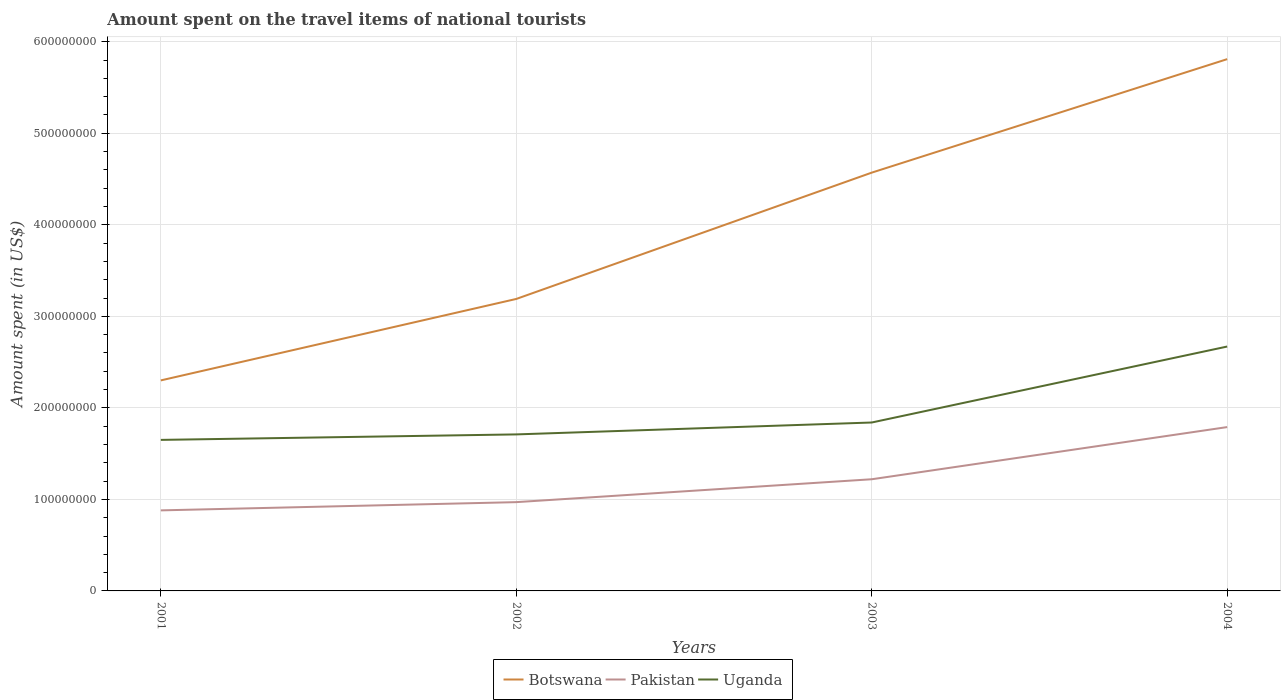Across all years, what is the maximum amount spent on the travel items of national tourists in Pakistan?
Your answer should be compact. 8.80e+07. In which year was the amount spent on the travel items of national tourists in Botswana maximum?
Ensure brevity in your answer.  2001. What is the total amount spent on the travel items of national tourists in Uganda in the graph?
Your answer should be very brief. -6.00e+06. What is the difference between the highest and the second highest amount spent on the travel items of national tourists in Uganda?
Offer a terse response. 1.02e+08. What is the difference between the highest and the lowest amount spent on the travel items of national tourists in Botswana?
Offer a very short reply. 2. Is the amount spent on the travel items of national tourists in Uganda strictly greater than the amount spent on the travel items of national tourists in Pakistan over the years?
Ensure brevity in your answer.  No. How many lines are there?
Make the answer very short. 3. Are the values on the major ticks of Y-axis written in scientific E-notation?
Your answer should be compact. No. How many legend labels are there?
Your answer should be very brief. 3. How are the legend labels stacked?
Offer a very short reply. Horizontal. What is the title of the graph?
Your answer should be compact. Amount spent on the travel items of national tourists. Does "Sub-Saharan Africa (developing only)" appear as one of the legend labels in the graph?
Offer a terse response. No. What is the label or title of the X-axis?
Offer a very short reply. Years. What is the label or title of the Y-axis?
Offer a terse response. Amount spent (in US$). What is the Amount spent (in US$) in Botswana in 2001?
Provide a succinct answer. 2.30e+08. What is the Amount spent (in US$) of Pakistan in 2001?
Your response must be concise. 8.80e+07. What is the Amount spent (in US$) in Uganda in 2001?
Offer a terse response. 1.65e+08. What is the Amount spent (in US$) in Botswana in 2002?
Give a very brief answer. 3.19e+08. What is the Amount spent (in US$) of Pakistan in 2002?
Make the answer very short. 9.70e+07. What is the Amount spent (in US$) of Uganda in 2002?
Offer a very short reply. 1.71e+08. What is the Amount spent (in US$) of Botswana in 2003?
Offer a terse response. 4.57e+08. What is the Amount spent (in US$) in Pakistan in 2003?
Give a very brief answer. 1.22e+08. What is the Amount spent (in US$) in Uganda in 2003?
Provide a succinct answer. 1.84e+08. What is the Amount spent (in US$) of Botswana in 2004?
Ensure brevity in your answer.  5.81e+08. What is the Amount spent (in US$) in Pakistan in 2004?
Make the answer very short. 1.79e+08. What is the Amount spent (in US$) in Uganda in 2004?
Offer a very short reply. 2.67e+08. Across all years, what is the maximum Amount spent (in US$) of Botswana?
Give a very brief answer. 5.81e+08. Across all years, what is the maximum Amount spent (in US$) of Pakistan?
Offer a terse response. 1.79e+08. Across all years, what is the maximum Amount spent (in US$) of Uganda?
Your answer should be compact. 2.67e+08. Across all years, what is the minimum Amount spent (in US$) in Botswana?
Offer a terse response. 2.30e+08. Across all years, what is the minimum Amount spent (in US$) in Pakistan?
Ensure brevity in your answer.  8.80e+07. Across all years, what is the minimum Amount spent (in US$) in Uganda?
Give a very brief answer. 1.65e+08. What is the total Amount spent (in US$) of Botswana in the graph?
Ensure brevity in your answer.  1.59e+09. What is the total Amount spent (in US$) of Pakistan in the graph?
Offer a very short reply. 4.86e+08. What is the total Amount spent (in US$) of Uganda in the graph?
Provide a short and direct response. 7.87e+08. What is the difference between the Amount spent (in US$) of Botswana in 2001 and that in 2002?
Your response must be concise. -8.90e+07. What is the difference between the Amount spent (in US$) in Pakistan in 2001 and that in 2002?
Make the answer very short. -9.00e+06. What is the difference between the Amount spent (in US$) in Uganda in 2001 and that in 2002?
Offer a terse response. -6.00e+06. What is the difference between the Amount spent (in US$) in Botswana in 2001 and that in 2003?
Your answer should be compact. -2.27e+08. What is the difference between the Amount spent (in US$) in Pakistan in 2001 and that in 2003?
Keep it short and to the point. -3.40e+07. What is the difference between the Amount spent (in US$) in Uganda in 2001 and that in 2003?
Your response must be concise. -1.90e+07. What is the difference between the Amount spent (in US$) in Botswana in 2001 and that in 2004?
Your answer should be very brief. -3.51e+08. What is the difference between the Amount spent (in US$) in Pakistan in 2001 and that in 2004?
Your response must be concise. -9.10e+07. What is the difference between the Amount spent (in US$) of Uganda in 2001 and that in 2004?
Keep it short and to the point. -1.02e+08. What is the difference between the Amount spent (in US$) in Botswana in 2002 and that in 2003?
Give a very brief answer. -1.38e+08. What is the difference between the Amount spent (in US$) of Pakistan in 2002 and that in 2003?
Your answer should be very brief. -2.50e+07. What is the difference between the Amount spent (in US$) of Uganda in 2002 and that in 2003?
Your response must be concise. -1.30e+07. What is the difference between the Amount spent (in US$) of Botswana in 2002 and that in 2004?
Your answer should be compact. -2.62e+08. What is the difference between the Amount spent (in US$) of Pakistan in 2002 and that in 2004?
Your answer should be very brief. -8.20e+07. What is the difference between the Amount spent (in US$) of Uganda in 2002 and that in 2004?
Your answer should be very brief. -9.60e+07. What is the difference between the Amount spent (in US$) of Botswana in 2003 and that in 2004?
Offer a very short reply. -1.24e+08. What is the difference between the Amount spent (in US$) in Pakistan in 2003 and that in 2004?
Keep it short and to the point. -5.70e+07. What is the difference between the Amount spent (in US$) of Uganda in 2003 and that in 2004?
Keep it short and to the point. -8.30e+07. What is the difference between the Amount spent (in US$) in Botswana in 2001 and the Amount spent (in US$) in Pakistan in 2002?
Your answer should be very brief. 1.33e+08. What is the difference between the Amount spent (in US$) of Botswana in 2001 and the Amount spent (in US$) of Uganda in 2002?
Give a very brief answer. 5.90e+07. What is the difference between the Amount spent (in US$) in Pakistan in 2001 and the Amount spent (in US$) in Uganda in 2002?
Give a very brief answer. -8.30e+07. What is the difference between the Amount spent (in US$) in Botswana in 2001 and the Amount spent (in US$) in Pakistan in 2003?
Provide a short and direct response. 1.08e+08. What is the difference between the Amount spent (in US$) in Botswana in 2001 and the Amount spent (in US$) in Uganda in 2003?
Offer a very short reply. 4.60e+07. What is the difference between the Amount spent (in US$) of Pakistan in 2001 and the Amount spent (in US$) of Uganda in 2003?
Keep it short and to the point. -9.60e+07. What is the difference between the Amount spent (in US$) in Botswana in 2001 and the Amount spent (in US$) in Pakistan in 2004?
Keep it short and to the point. 5.10e+07. What is the difference between the Amount spent (in US$) of Botswana in 2001 and the Amount spent (in US$) of Uganda in 2004?
Give a very brief answer. -3.70e+07. What is the difference between the Amount spent (in US$) of Pakistan in 2001 and the Amount spent (in US$) of Uganda in 2004?
Provide a succinct answer. -1.79e+08. What is the difference between the Amount spent (in US$) of Botswana in 2002 and the Amount spent (in US$) of Pakistan in 2003?
Ensure brevity in your answer.  1.97e+08. What is the difference between the Amount spent (in US$) in Botswana in 2002 and the Amount spent (in US$) in Uganda in 2003?
Your answer should be very brief. 1.35e+08. What is the difference between the Amount spent (in US$) of Pakistan in 2002 and the Amount spent (in US$) of Uganda in 2003?
Keep it short and to the point. -8.70e+07. What is the difference between the Amount spent (in US$) in Botswana in 2002 and the Amount spent (in US$) in Pakistan in 2004?
Offer a terse response. 1.40e+08. What is the difference between the Amount spent (in US$) in Botswana in 2002 and the Amount spent (in US$) in Uganda in 2004?
Offer a terse response. 5.20e+07. What is the difference between the Amount spent (in US$) in Pakistan in 2002 and the Amount spent (in US$) in Uganda in 2004?
Your response must be concise. -1.70e+08. What is the difference between the Amount spent (in US$) of Botswana in 2003 and the Amount spent (in US$) of Pakistan in 2004?
Ensure brevity in your answer.  2.78e+08. What is the difference between the Amount spent (in US$) of Botswana in 2003 and the Amount spent (in US$) of Uganda in 2004?
Provide a short and direct response. 1.90e+08. What is the difference between the Amount spent (in US$) in Pakistan in 2003 and the Amount spent (in US$) in Uganda in 2004?
Provide a succinct answer. -1.45e+08. What is the average Amount spent (in US$) in Botswana per year?
Provide a short and direct response. 3.97e+08. What is the average Amount spent (in US$) of Pakistan per year?
Keep it short and to the point. 1.22e+08. What is the average Amount spent (in US$) in Uganda per year?
Your answer should be very brief. 1.97e+08. In the year 2001, what is the difference between the Amount spent (in US$) of Botswana and Amount spent (in US$) of Pakistan?
Ensure brevity in your answer.  1.42e+08. In the year 2001, what is the difference between the Amount spent (in US$) in Botswana and Amount spent (in US$) in Uganda?
Provide a succinct answer. 6.50e+07. In the year 2001, what is the difference between the Amount spent (in US$) in Pakistan and Amount spent (in US$) in Uganda?
Provide a short and direct response. -7.70e+07. In the year 2002, what is the difference between the Amount spent (in US$) of Botswana and Amount spent (in US$) of Pakistan?
Your answer should be very brief. 2.22e+08. In the year 2002, what is the difference between the Amount spent (in US$) of Botswana and Amount spent (in US$) of Uganda?
Your answer should be compact. 1.48e+08. In the year 2002, what is the difference between the Amount spent (in US$) in Pakistan and Amount spent (in US$) in Uganda?
Your answer should be compact. -7.40e+07. In the year 2003, what is the difference between the Amount spent (in US$) of Botswana and Amount spent (in US$) of Pakistan?
Provide a succinct answer. 3.35e+08. In the year 2003, what is the difference between the Amount spent (in US$) in Botswana and Amount spent (in US$) in Uganda?
Your answer should be compact. 2.73e+08. In the year 2003, what is the difference between the Amount spent (in US$) in Pakistan and Amount spent (in US$) in Uganda?
Ensure brevity in your answer.  -6.20e+07. In the year 2004, what is the difference between the Amount spent (in US$) in Botswana and Amount spent (in US$) in Pakistan?
Make the answer very short. 4.02e+08. In the year 2004, what is the difference between the Amount spent (in US$) in Botswana and Amount spent (in US$) in Uganda?
Make the answer very short. 3.14e+08. In the year 2004, what is the difference between the Amount spent (in US$) of Pakistan and Amount spent (in US$) of Uganda?
Your answer should be compact. -8.80e+07. What is the ratio of the Amount spent (in US$) in Botswana in 2001 to that in 2002?
Keep it short and to the point. 0.72. What is the ratio of the Amount spent (in US$) in Pakistan in 2001 to that in 2002?
Keep it short and to the point. 0.91. What is the ratio of the Amount spent (in US$) in Uganda in 2001 to that in 2002?
Your response must be concise. 0.96. What is the ratio of the Amount spent (in US$) in Botswana in 2001 to that in 2003?
Offer a very short reply. 0.5. What is the ratio of the Amount spent (in US$) in Pakistan in 2001 to that in 2003?
Provide a short and direct response. 0.72. What is the ratio of the Amount spent (in US$) of Uganda in 2001 to that in 2003?
Make the answer very short. 0.9. What is the ratio of the Amount spent (in US$) in Botswana in 2001 to that in 2004?
Your answer should be very brief. 0.4. What is the ratio of the Amount spent (in US$) of Pakistan in 2001 to that in 2004?
Ensure brevity in your answer.  0.49. What is the ratio of the Amount spent (in US$) of Uganda in 2001 to that in 2004?
Your answer should be very brief. 0.62. What is the ratio of the Amount spent (in US$) of Botswana in 2002 to that in 2003?
Provide a succinct answer. 0.7. What is the ratio of the Amount spent (in US$) in Pakistan in 2002 to that in 2003?
Ensure brevity in your answer.  0.8. What is the ratio of the Amount spent (in US$) of Uganda in 2002 to that in 2003?
Your response must be concise. 0.93. What is the ratio of the Amount spent (in US$) of Botswana in 2002 to that in 2004?
Provide a succinct answer. 0.55. What is the ratio of the Amount spent (in US$) of Pakistan in 2002 to that in 2004?
Offer a very short reply. 0.54. What is the ratio of the Amount spent (in US$) in Uganda in 2002 to that in 2004?
Ensure brevity in your answer.  0.64. What is the ratio of the Amount spent (in US$) of Botswana in 2003 to that in 2004?
Your answer should be compact. 0.79. What is the ratio of the Amount spent (in US$) in Pakistan in 2003 to that in 2004?
Keep it short and to the point. 0.68. What is the ratio of the Amount spent (in US$) of Uganda in 2003 to that in 2004?
Your answer should be compact. 0.69. What is the difference between the highest and the second highest Amount spent (in US$) in Botswana?
Make the answer very short. 1.24e+08. What is the difference between the highest and the second highest Amount spent (in US$) in Pakistan?
Your answer should be very brief. 5.70e+07. What is the difference between the highest and the second highest Amount spent (in US$) in Uganda?
Make the answer very short. 8.30e+07. What is the difference between the highest and the lowest Amount spent (in US$) of Botswana?
Provide a succinct answer. 3.51e+08. What is the difference between the highest and the lowest Amount spent (in US$) in Pakistan?
Make the answer very short. 9.10e+07. What is the difference between the highest and the lowest Amount spent (in US$) of Uganda?
Your answer should be compact. 1.02e+08. 